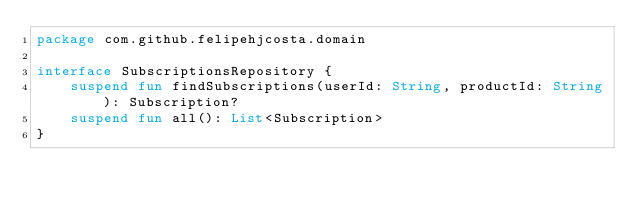Convert code to text. <code><loc_0><loc_0><loc_500><loc_500><_Kotlin_>package com.github.felipehjcosta.domain

interface SubscriptionsRepository {
    suspend fun findSubscriptions(userId: String, productId: String): Subscription?
    suspend fun all(): List<Subscription>
}
</code> 